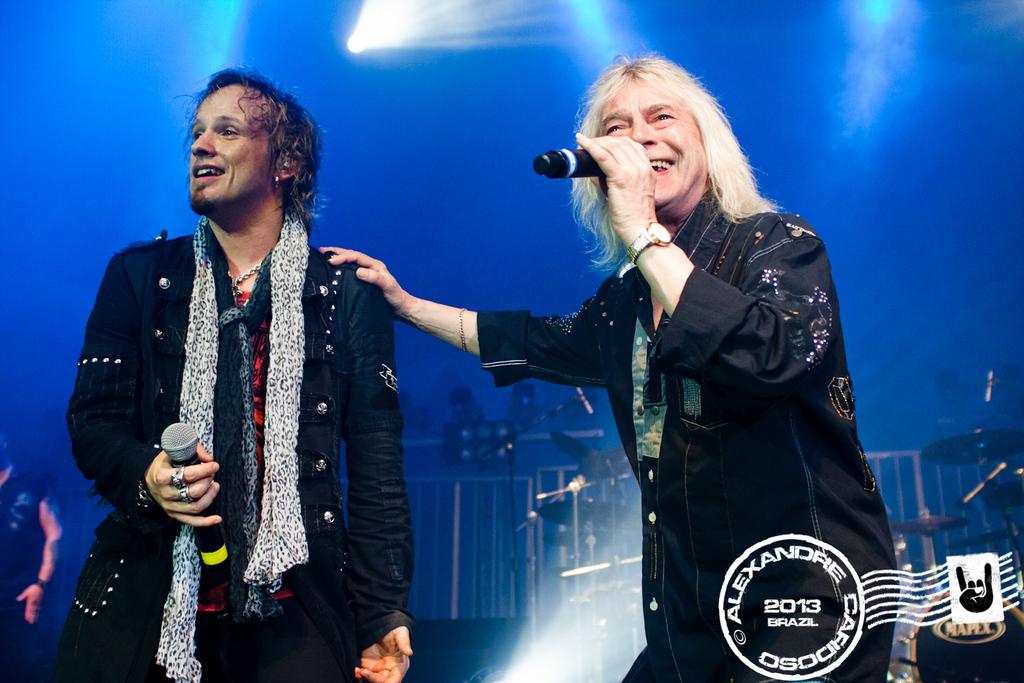What year was this stamped?
Your response must be concise. 2013. What country is just under the year on the seal?
Your response must be concise. Brazil. 